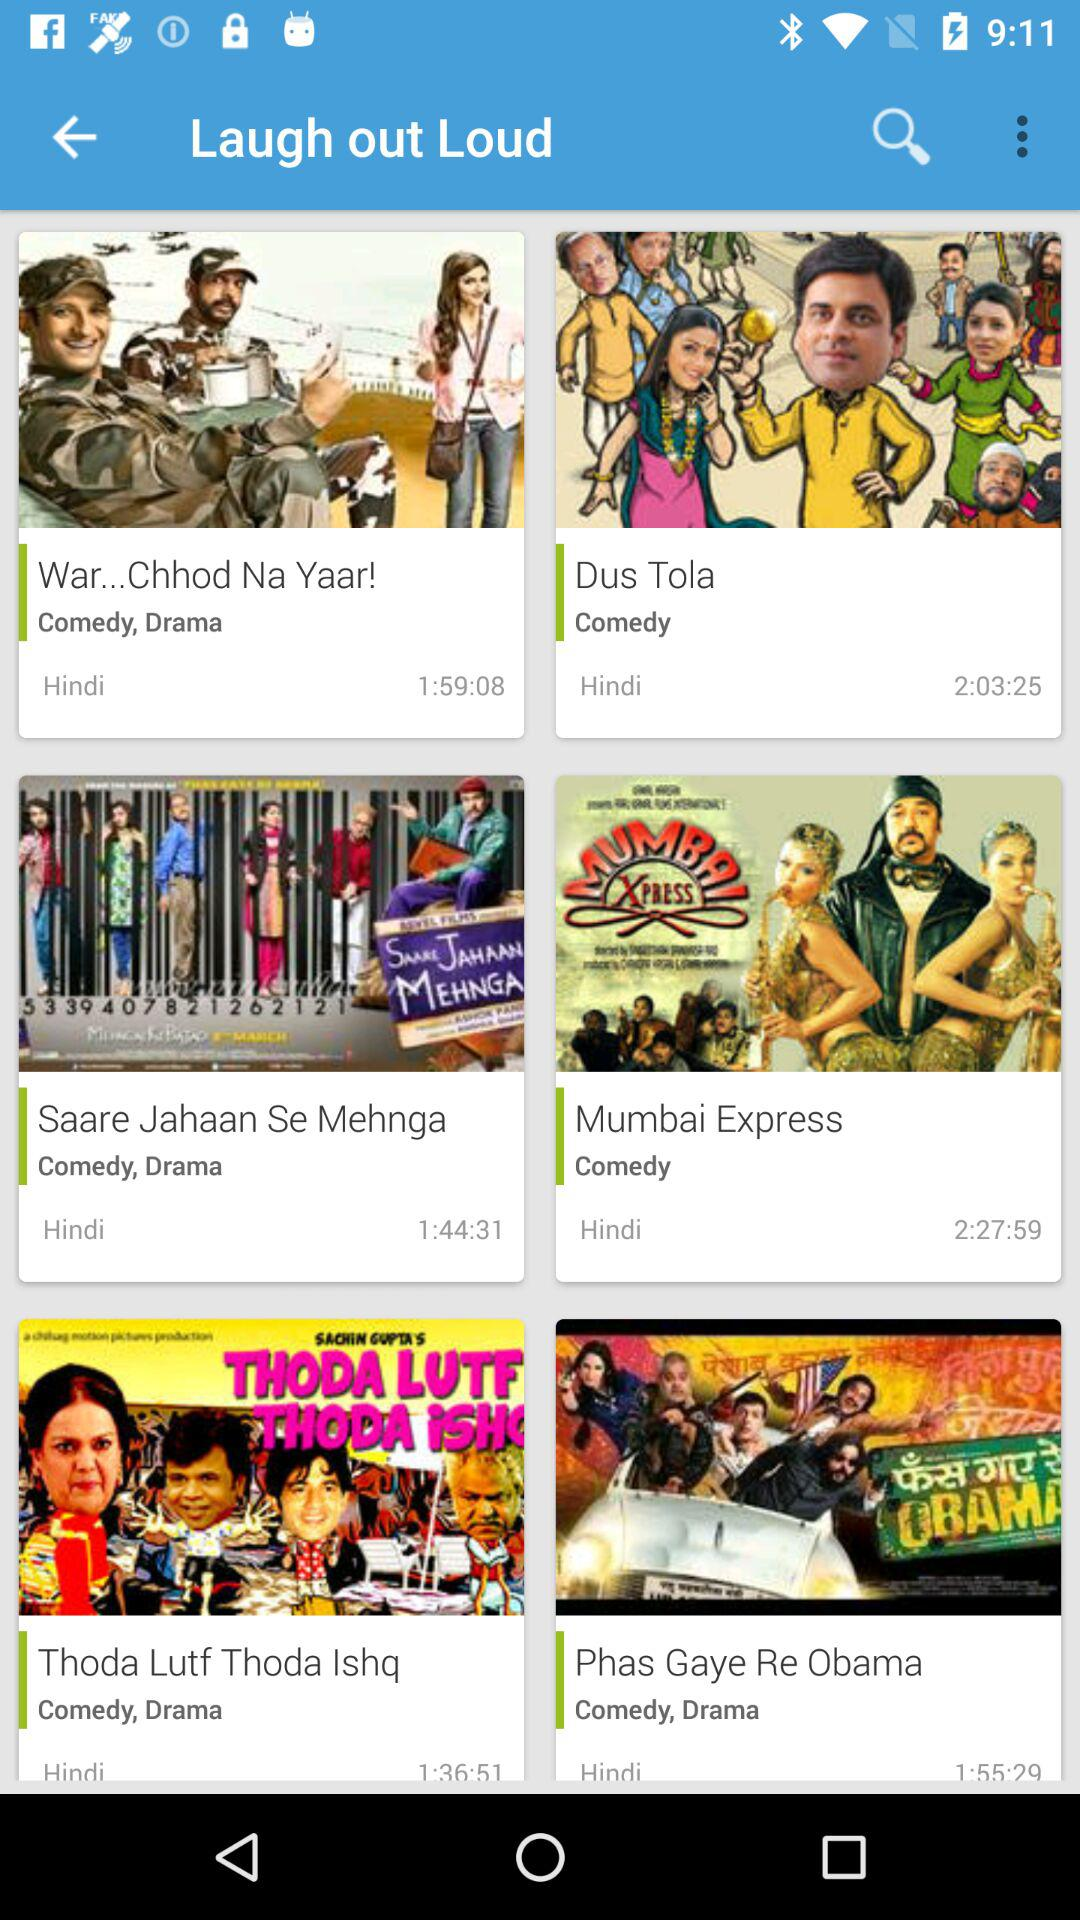What type of movie is "War...Chhod Na Yaar!"? The movie type is comedy and drama. 